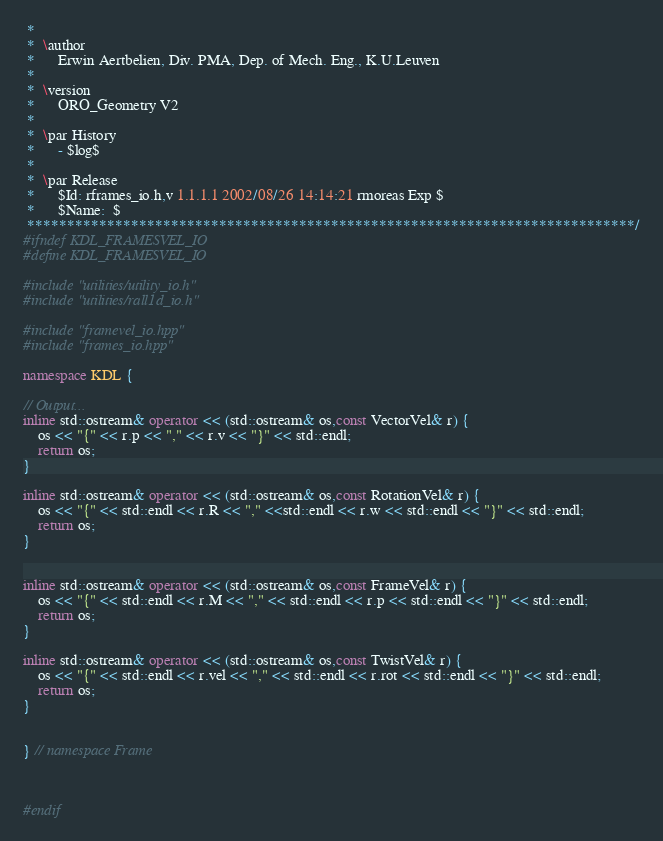<code> <loc_0><loc_0><loc_500><loc_500><_C++_> *
 *  \author
 *      Erwin Aertbelien, Div. PMA, Dep. of Mech. Eng., K.U.Leuven
 *
 *  \version
 *      ORO_Geometry V2
 *
 *  \par History
 *      - $log$
 *
 *  \par Release
 *      $Id: rframes_io.h,v 1.1.1.1 2002/08/26 14:14:21 rmoreas Exp $
 *      $Name:  $
 ****************************************************************************/
#ifndef KDL_FRAMESVEL_IO
#define KDL_FRAMESVEL_IO

#include "utilities/utility_io.h"
#include "utilities/rall1d_io.h"

#include "framevel_io.hpp"
#include "frames_io.hpp"

namespace KDL {

// Output...
inline std::ostream& operator << (std::ostream& os,const VectorVel& r) {
    os << "{" << r.p << "," << r.v << "}" << std::endl;
    return os;
}

inline std::ostream& operator << (std::ostream& os,const RotationVel& r) {
    os << "{" << std::endl << r.R << "," <<std::endl << r.w << std::endl << "}" << std::endl;
    return os;
}


inline std::ostream& operator << (std::ostream& os,const FrameVel& r) {
    os << "{" << std::endl << r.M << "," << std::endl << r.p << std::endl << "}" << std::endl;
    return os;
}

inline std::ostream& operator << (std::ostream& os,const TwistVel& r) {
    os << "{" << std::endl << r.vel << "," << std::endl << r.rot << std::endl << "}" << std::endl;
    return os;
}


} // namespace Frame



#endif
</code> 